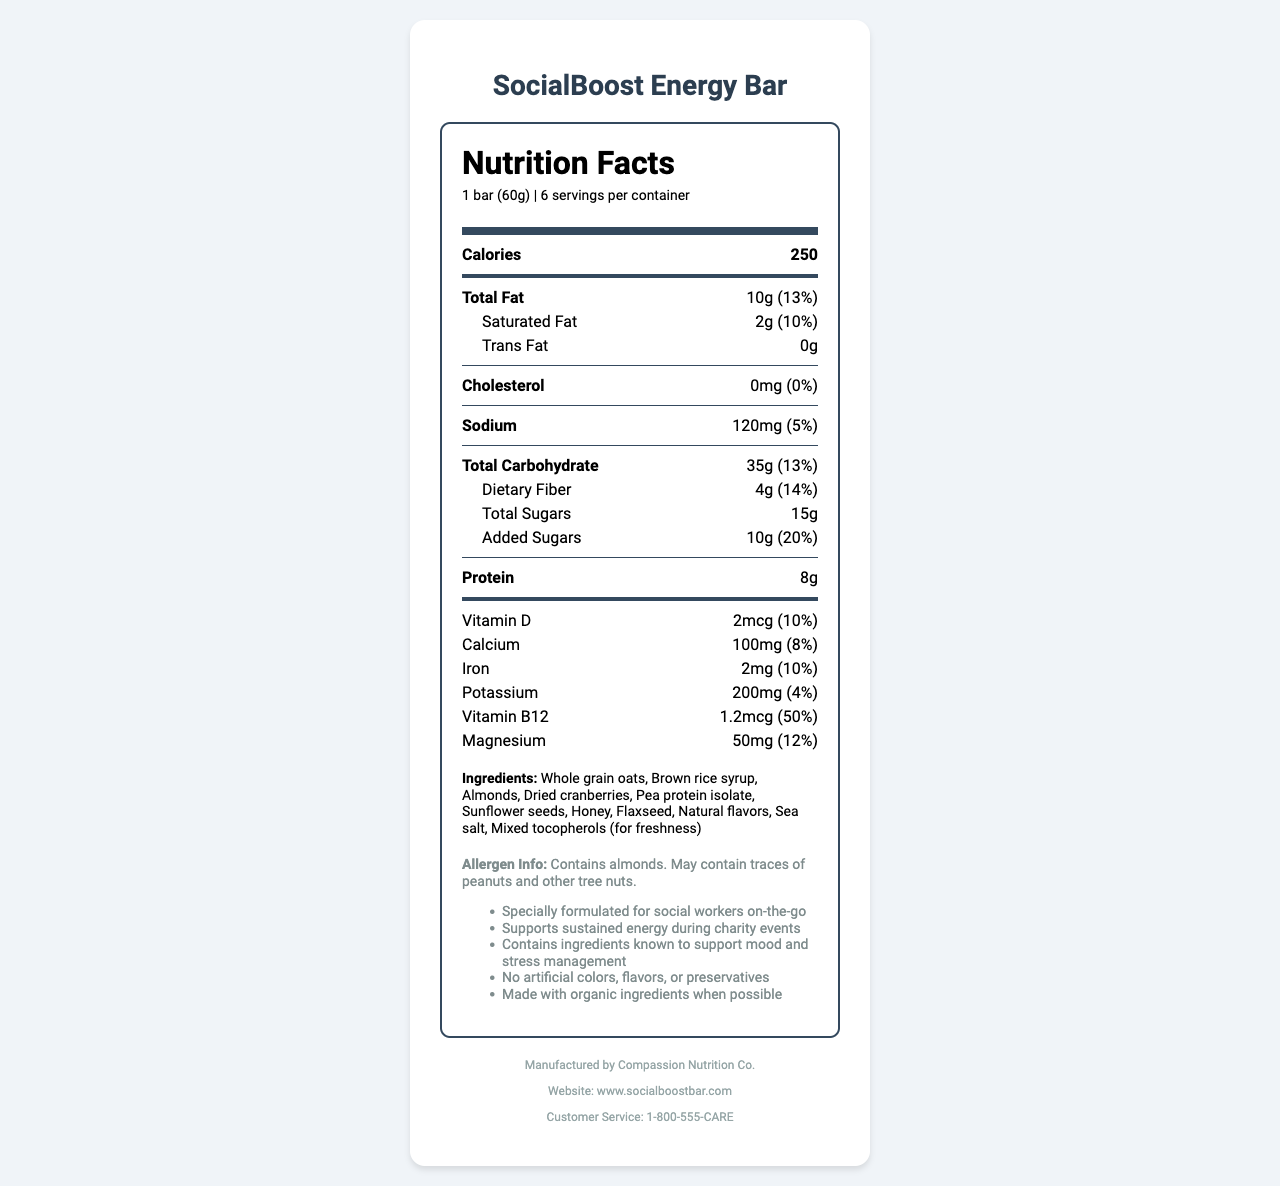what is the serving size for the SocialBoost Energy Bar? The serving size is explicitly stated as 1 bar (60g) in the document.
Answer: 1 bar (60g) how many calories are in one serving of the SocialBoost Energy Bar? The document lists the calories per serving as 250.
Answer: 250 what is the total amount of fat in one serving of the SocialBoost Energy Bar? The total fat amount is given as 10g per serving.
Answer: 10g how much protein does each bar contain? The amount of protein per serving is listed as 8g.
Answer: 8g what ingredients are included in the SocialBoost Energy Bar? Name three. The ingredients section lists whole grain oats, brown rice syrup, almonds, among others.
Answer: Whole grain oats, brown rice syrup, almonds how much dietary fiber is there per serving? The dietary fiber per serving is listed as 4g.
Answer: 4g what is the daily value percentage of vitamin D in the SocialBoost Energy Bar? The daily value percentage for vitamin D is stated as 10%.
Answer: 10% A. SocialBoost Energy Bar has 5g of total carbohydrates.
B. SocialBoost Energy Bar has 35g of total carbohydrates.
C. SocialBoost Energy Bar has 8g of total carbohydrates. The document states that the total carbohydrate content is 35g per serving.
Answer: B Which of the following nutrients has the highest daily value percentage in the SocialBoost Energy Bar? 
I. Vitamin B12
II. Vitamin D
III. Magnesium Vitamin B12 has the highest daily value percentage at 50%, compared to Vitamin D at 10% and Magnesium at 12%.
Answer: I does the SocialBoost Energy Bar contain any allergens? The document specifies that it contains almonds and may contain traces of peanuts and other tree nuts.
Answer: Yes summarize the key nutritional information of the SocialBoost Energy Bar and its purpose. The document gives a comprehensive overview of the product's nutritional values, ingredients, allergen information, and its specific benefits for social workers.
Answer: The SocialBoost Energy Bar, designed for social workers on-the-go during charity events, provides 250 calories per serving with a well-rounded mix of macronutrients: 10g of fat, 35g of carbohydrates, and 8g of protein. It also includes various vitamins and minerals, such as 10% DV of Vitamin D and 50% DV of Vitamin B12. The bar is formulated to support sustained energy and mood management and contains no artificial colors, flavors, or preservatives. is it possible to determine the expiry date of the SocialBoost Energy Bar from this document? The document does not provide any information regarding the expiry date of the product.
Answer: Not enough information what benefits are highlighted for social workers consuming the SocialBoost Energy Bar? The document mentions that the bar is specially formulated for social workers on-the-go, supporting sustained energy during charity events, and includes ingredients known to support mood and stress management.
Answer: Supports sustained energy, mood and stress management 